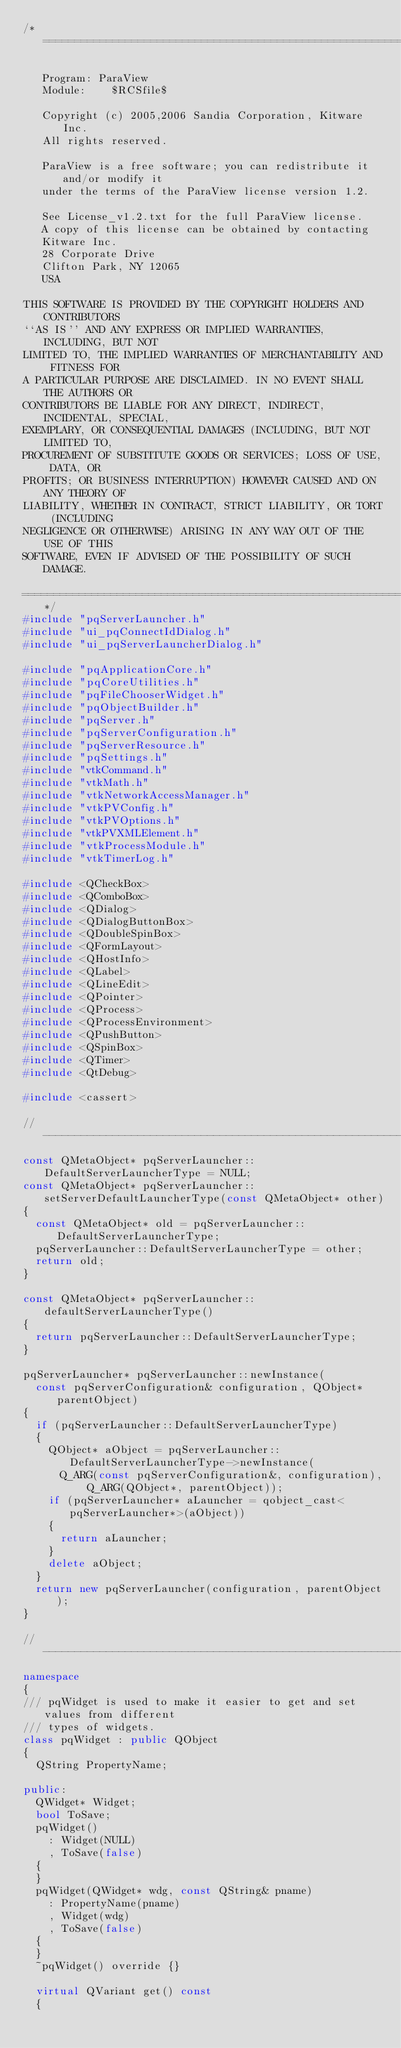Convert code to text. <code><loc_0><loc_0><loc_500><loc_500><_C++_>/*=========================================================================

   Program: ParaView
   Module:    $RCSfile$

   Copyright (c) 2005,2006 Sandia Corporation, Kitware Inc.
   All rights reserved.

   ParaView is a free software; you can redistribute it and/or modify it
   under the terms of the ParaView license version 1.2.

   See License_v1.2.txt for the full ParaView license.
   A copy of this license can be obtained by contacting
   Kitware Inc.
   28 Corporate Drive
   Clifton Park, NY 12065
   USA

THIS SOFTWARE IS PROVIDED BY THE COPYRIGHT HOLDERS AND CONTRIBUTORS
``AS IS'' AND ANY EXPRESS OR IMPLIED WARRANTIES, INCLUDING, BUT NOT
LIMITED TO, THE IMPLIED WARRANTIES OF MERCHANTABILITY AND FITNESS FOR
A PARTICULAR PURPOSE ARE DISCLAIMED. IN NO EVENT SHALL THE AUTHORS OR
CONTRIBUTORS BE LIABLE FOR ANY DIRECT, INDIRECT, INCIDENTAL, SPECIAL,
EXEMPLARY, OR CONSEQUENTIAL DAMAGES (INCLUDING, BUT NOT LIMITED TO,
PROCUREMENT OF SUBSTITUTE GOODS OR SERVICES; LOSS OF USE, DATA, OR
PROFITS; OR BUSINESS INTERRUPTION) HOWEVER CAUSED AND ON ANY THEORY OF
LIABILITY, WHETHER IN CONTRACT, STRICT LIABILITY, OR TORT (INCLUDING
NEGLIGENCE OR OTHERWISE) ARISING IN ANY WAY OUT OF THE USE OF THIS
SOFTWARE, EVEN IF ADVISED OF THE POSSIBILITY OF SUCH DAMAGE.

========================================================================*/
#include "pqServerLauncher.h"
#include "ui_pqConnectIdDialog.h"
#include "ui_pqServerLauncherDialog.h"

#include "pqApplicationCore.h"
#include "pqCoreUtilities.h"
#include "pqFileChooserWidget.h"
#include "pqObjectBuilder.h"
#include "pqServer.h"
#include "pqServerConfiguration.h"
#include "pqServerResource.h"
#include "pqSettings.h"
#include "vtkCommand.h"
#include "vtkMath.h"
#include "vtkNetworkAccessManager.h"
#include "vtkPVConfig.h"
#include "vtkPVOptions.h"
#include "vtkPVXMLElement.h"
#include "vtkProcessModule.h"
#include "vtkTimerLog.h"

#include <QCheckBox>
#include <QComboBox>
#include <QDialog>
#include <QDialogButtonBox>
#include <QDoubleSpinBox>
#include <QFormLayout>
#include <QHostInfo>
#include <QLabel>
#include <QLineEdit>
#include <QPointer>
#include <QProcess>
#include <QProcessEnvironment>
#include <QPushButton>
#include <QSpinBox>
#include <QTimer>
#include <QtDebug>

#include <cassert>

//----------------------------------------------------------------------------
const QMetaObject* pqServerLauncher::DefaultServerLauncherType = NULL;
const QMetaObject* pqServerLauncher::setServerDefaultLauncherType(const QMetaObject* other)
{
  const QMetaObject* old = pqServerLauncher::DefaultServerLauncherType;
  pqServerLauncher::DefaultServerLauncherType = other;
  return old;
}

const QMetaObject* pqServerLauncher::defaultServerLauncherType()
{
  return pqServerLauncher::DefaultServerLauncherType;
}

pqServerLauncher* pqServerLauncher::newInstance(
  const pqServerConfiguration& configuration, QObject* parentObject)
{
  if (pqServerLauncher::DefaultServerLauncherType)
  {
    QObject* aObject = pqServerLauncher::DefaultServerLauncherType->newInstance(
      Q_ARG(const pqServerConfiguration&, configuration), Q_ARG(QObject*, parentObject));
    if (pqServerLauncher* aLauncher = qobject_cast<pqServerLauncher*>(aObject))
    {
      return aLauncher;
    }
    delete aObject;
  }
  return new pqServerLauncher(configuration, parentObject);
}

//----------------------------------------------------------------------------
namespace
{
/// pqWidget is used to make it easier to get and set values from different
/// types of widgets.
class pqWidget : public QObject
{
  QString PropertyName;

public:
  QWidget* Widget;
  bool ToSave;
  pqWidget()
    : Widget(NULL)
    , ToSave(false)
  {
  }
  pqWidget(QWidget* wdg, const QString& pname)
    : PropertyName(pname)
    , Widget(wdg)
    , ToSave(false)
  {
  }
  ~pqWidget() override {}

  virtual QVariant get() const
  {</code> 